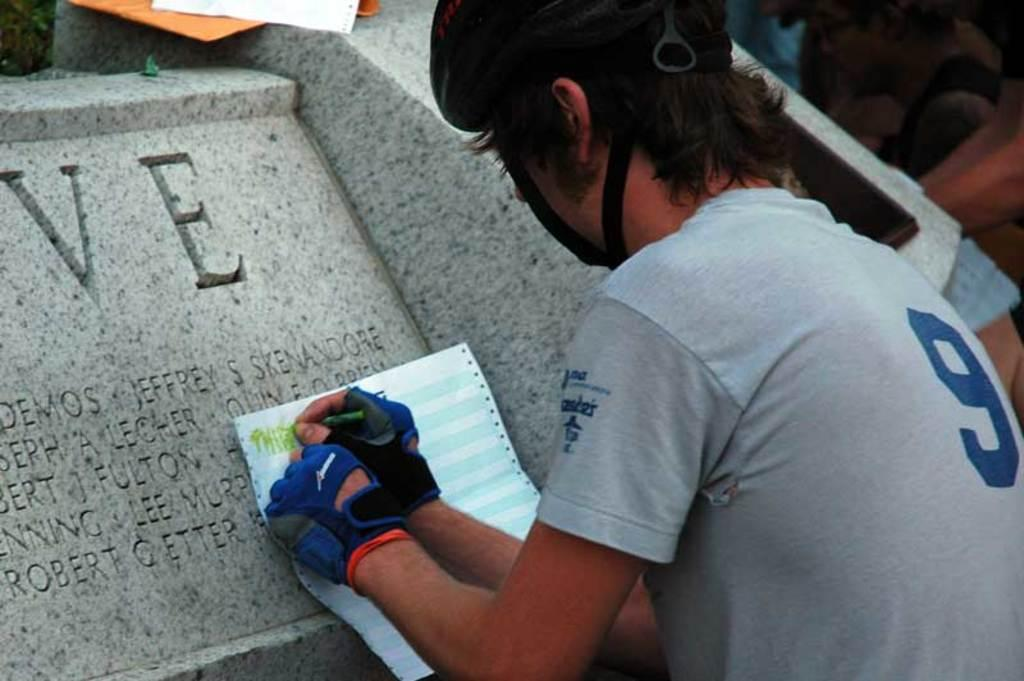How many people are in the image? There are a few people in the image. What is one person doing in the image? One person is holding an object. What type of objects are present with text on them in the image? There are stones with text in the image. What can be seen at the top of the image? There are objects visible at the top of the image. What is the belief system of the people in the image? There is no information about the belief system of the people in the image. Is there any evidence of war in the image? There is no evidence of war in the image. 